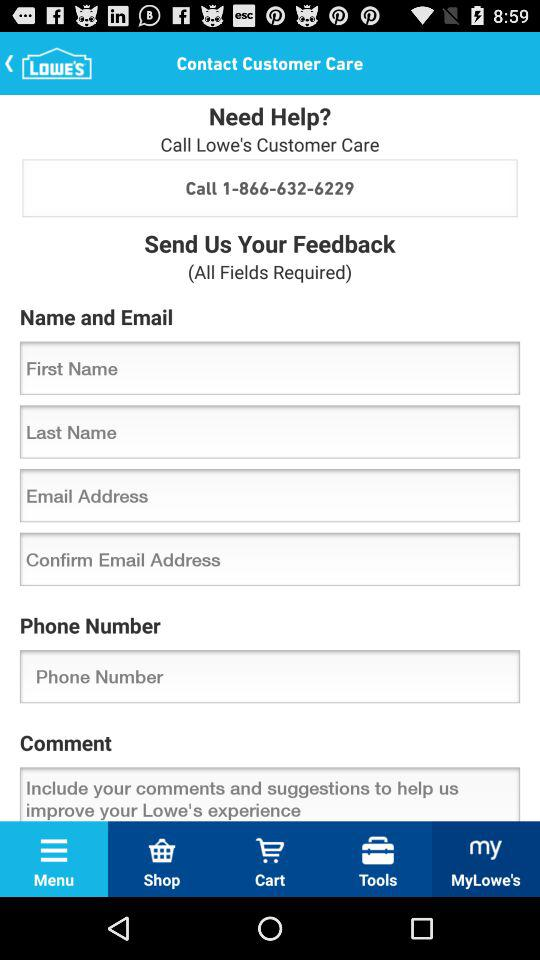What is the customer care contact number? The customer care contact number is 1-866-632-6229. 